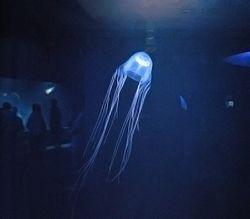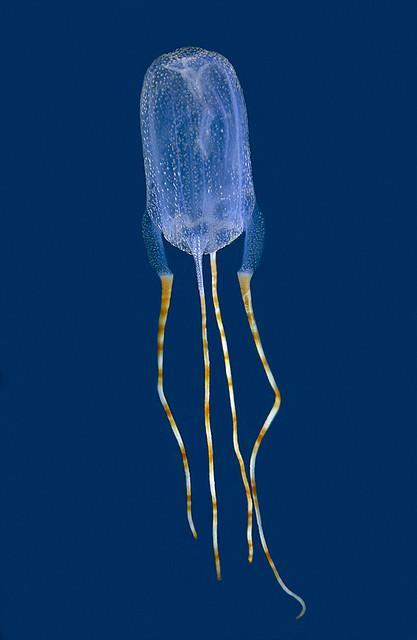The first image is the image on the left, the second image is the image on the right. Given the left and right images, does the statement "There are multiple jellyfish in the image on the left." hold true? Answer yes or no. No. The first image is the image on the left, the second image is the image on the right. Analyze the images presented: Is the assertion "All jellyfish have translucent glowing bluish bodies, and all trail slender tendrils." valid? Answer yes or no. Yes. 